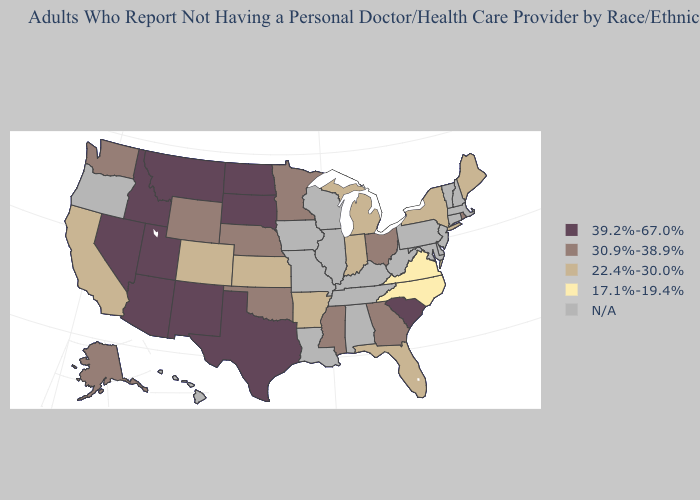What is the highest value in states that border Idaho?
Concise answer only. 39.2%-67.0%. Among the states that border Kansas , which have the lowest value?
Give a very brief answer. Colorado. What is the value of Wisconsin?
Answer briefly. N/A. Does Kansas have the lowest value in the MidWest?
Keep it brief. Yes. What is the lowest value in the USA?
Keep it brief. 17.1%-19.4%. Which states have the lowest value in the USA?
Keep it brief. North Carolina, Virginia. Name the states that have a value in the range 17.1%-19.4%?
Answer briefly. North Carolina, Virginia. Name the states that have a value in the range 22.4%-30.0%?
Answer briefly. Arkansas, California, Colorado, Florida, Indiana, Kansas, Maine, Michigan, New York. What is the lowest value in the USA?
Be succinct. 17.1%-19.4%. What is the highest value in states that border California?
Give a very brief answer. 39.2%-67.0%. What is the highest value in the USA?
Be succinct. 39.2%-67.0%. Name the states that have a value in the range 30.9%-38.9%?
Keep it brief. Alaska, Georgia, Minnesota, Mississippi, Nebraska, Ohio, Oklahoma, Rhode Island, Washington, Wyoming. Among the states that border Michigan , which have the lowest value?
Quick response, please. Indiana. Does Utah have the highest value in the USA?
Answer briefly. Yes. 